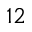<formula> <loc_0><loc_0><loc_500><loc_500>^ { 1 2 }</formula> 